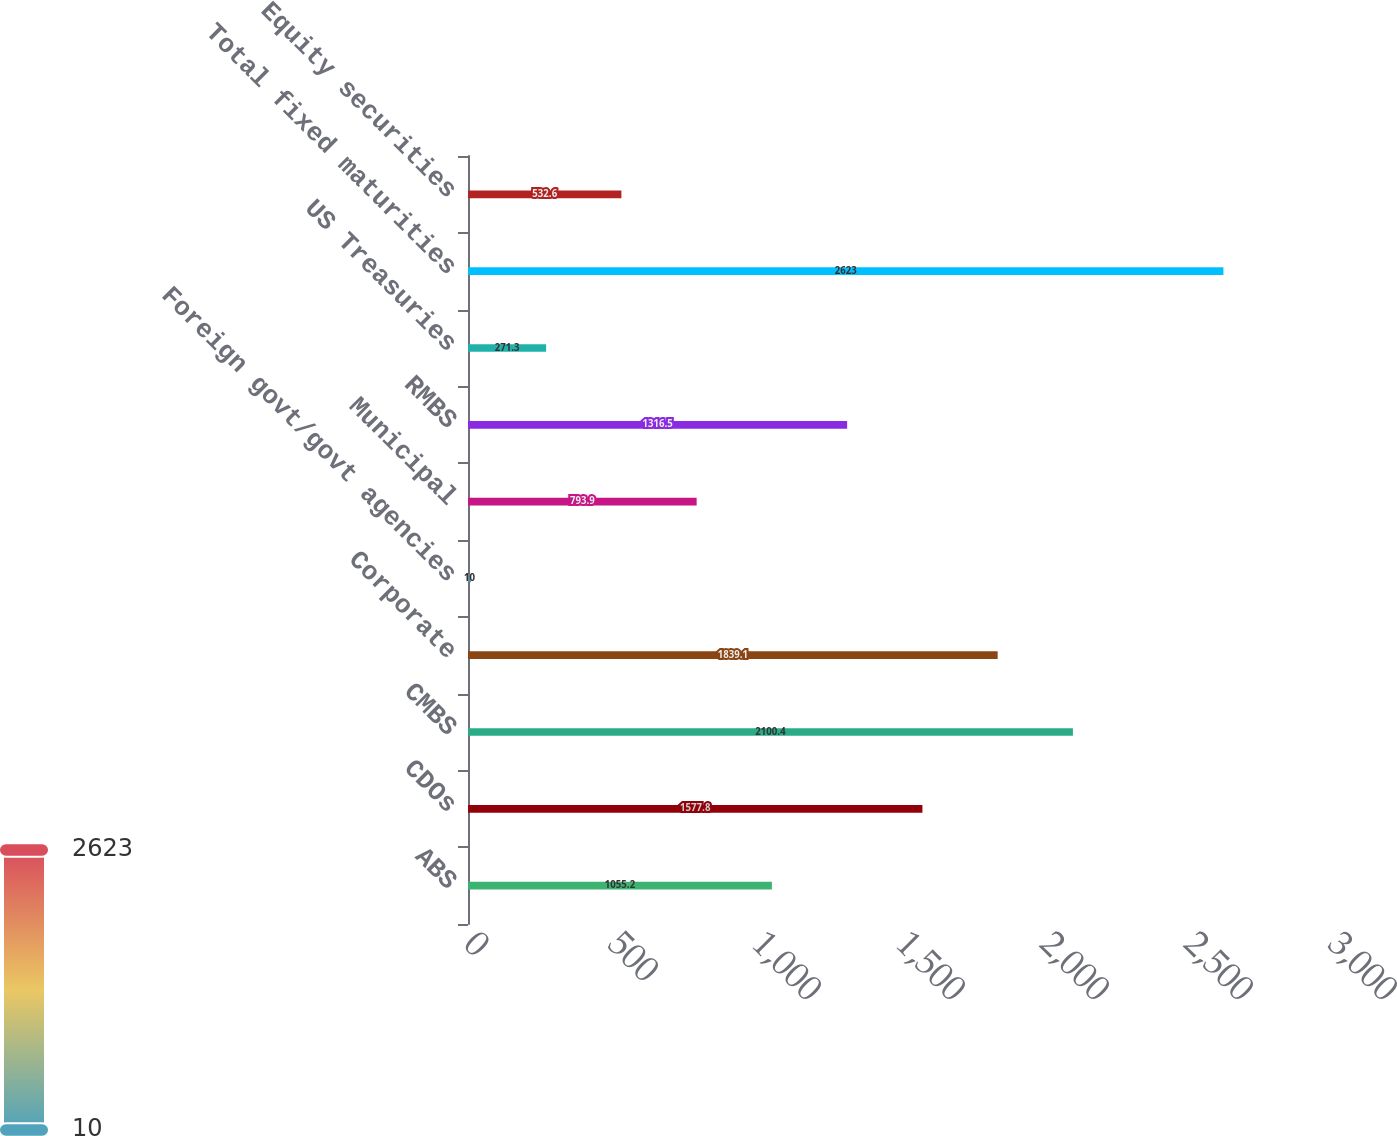Convert chart to OTSL. <chart><loc_0><loc_0><loc_500><loc_500><bar_chart><fcel>ABS<fcel>CDOs<fcel>CMBS<fcel>Corporate<fcel>Foreign govt/govt agencies<fcel>Municipal<fcel>RMBS<fcel>US Treasuries<fcel>Total fixed maturities<fcel>Equity securities<nl><fcel>1055.2<fcel>1577.8<fcel>2100.4<fcel>1839.1<fcel>10<fcel>793.9<fcel>1316.5<fcel>271.3<fcel>2623<fcel>532.6<nl></chart> 